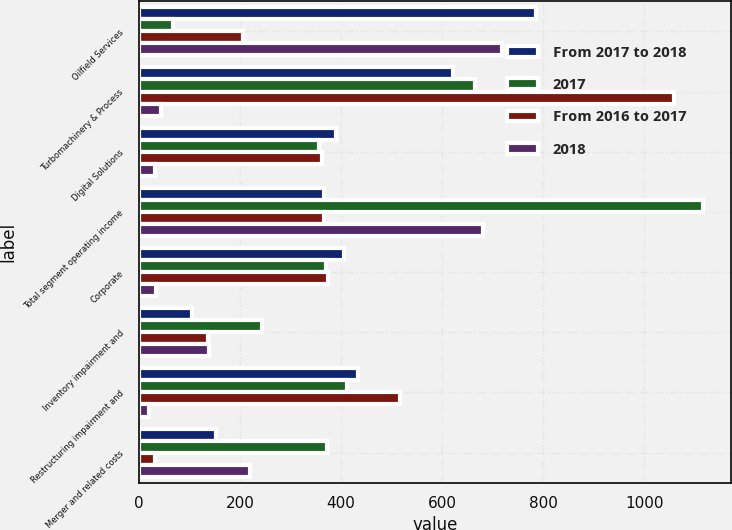Convert chart to OTSL. <chart><loc_0><loc_0><loc_500><loc_500><stacked_bar_chart><ecel><fcel>Oilfield Services<fcel>Turbomachinery & Process<fcel>Digital Solutions<fcel>Total segment operating income<fcel>Corporate<fcel>Inventory impairment and<fcel>Restructuring impairment and<fcel>Merger and related costs<nl><fcel>From 2017 to 2018<fcel>785<fcel>621<fcel>390<fcel>366.5<fcel>405<fcel>105<fcel>433<fcel>153<nl><fcel>2017<fcel>67<fcel>665<fcel>357<fcel>1115<fcel>370<fcel>244<fcel>412<fcel>373<nl><fcel>From 2016 to 2017<fcel>207<fcel>1058<fcel>363<fcel>366.5<fcel>375<fcel>138<fcel>516<fcel>33<nl><fcel>2018<fcel>718<fcel>44<fcel>33<fcel>681<fcel>35<fcel>139<fcel>21<fcel>220<nl></chart> 